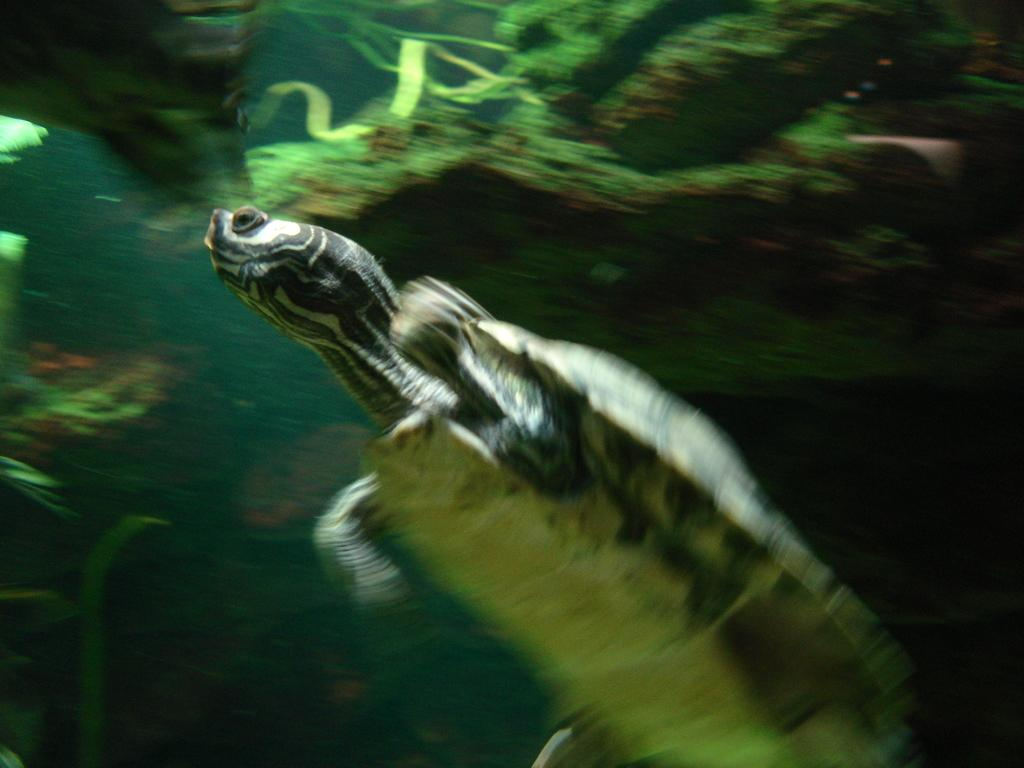What animal is present in the image? There is a tortoise in the image. What is the tortoise doing in the image? The tortoise is swimming in the water. What can be seen in the background of the image? There are marine plants visible in the background of the image. How many sisters does the tortoise have in the image? There is no mention of sisters or any other animals in the image, so it cannot be determined. 